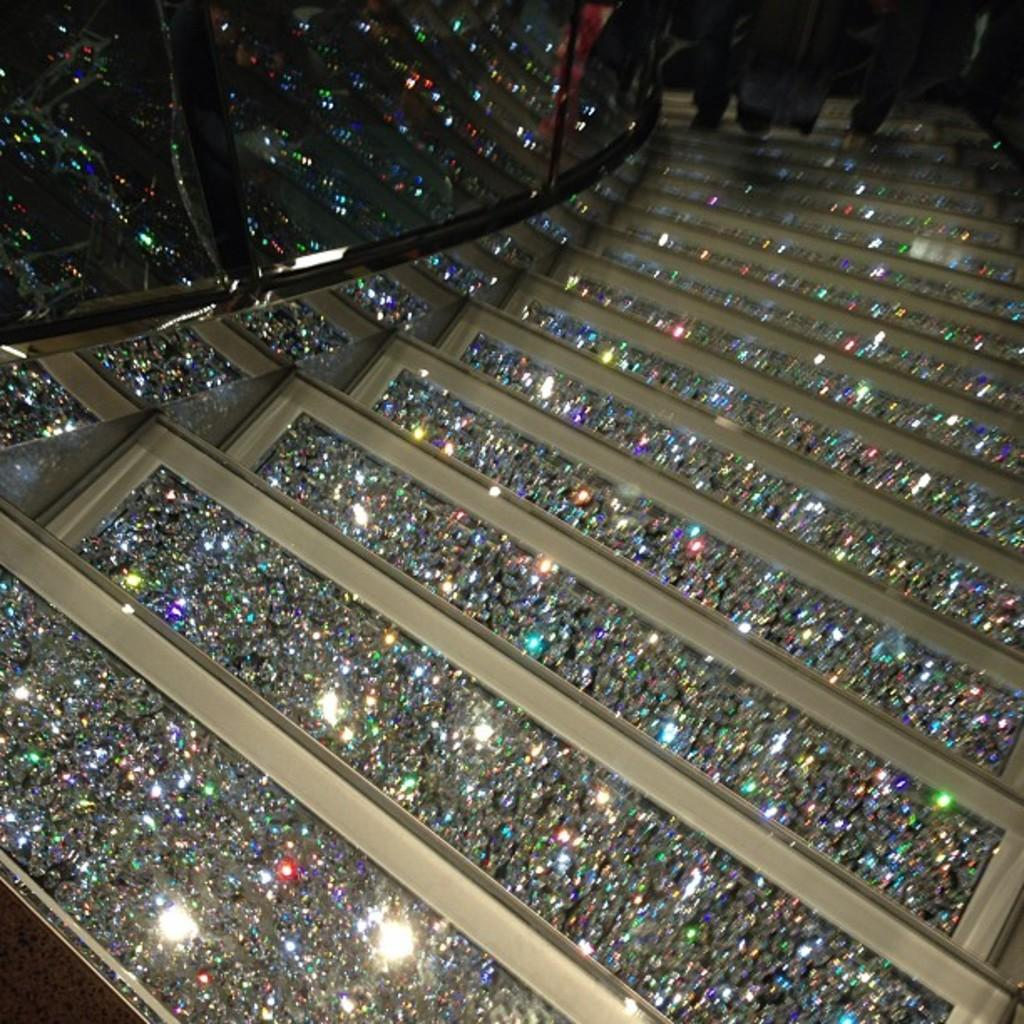What type of structure is present in the image? There are stairs in the image. What feature is visible at the top of the stairs? Railing is visible at the top of the image. Are there any people in the image? Yes, there are people at the top of the image. How does the earthquake affect the stability of the stairs in the image? There is no earthquake present in the image, so its effect on the stairs cannot be determined. 